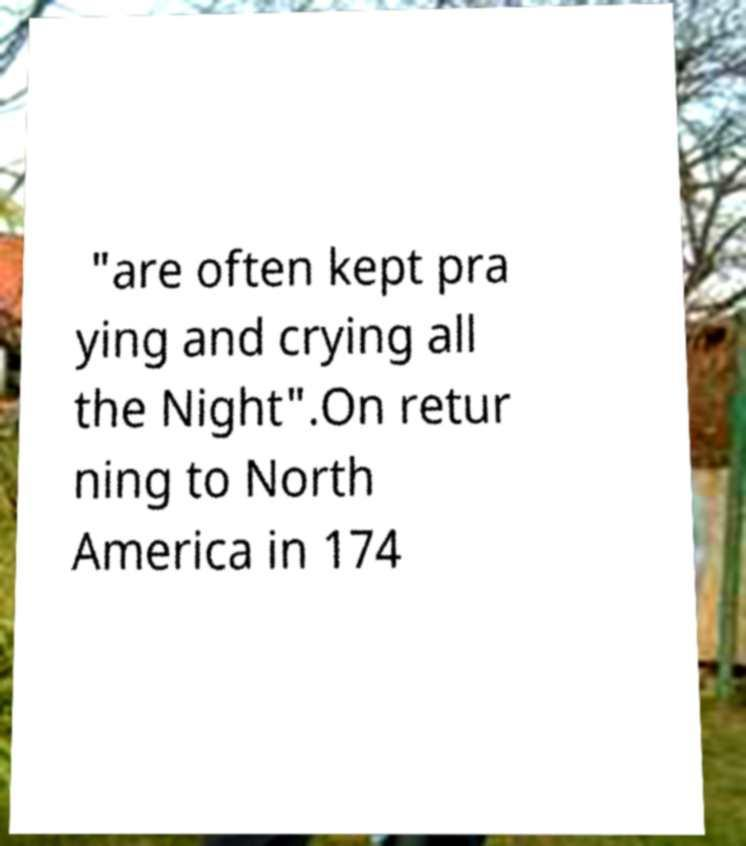I need the written content from this picture converted into text. Can you do that? "are often kept pra ying and crying all the Night".On retur ning to North America in 174 